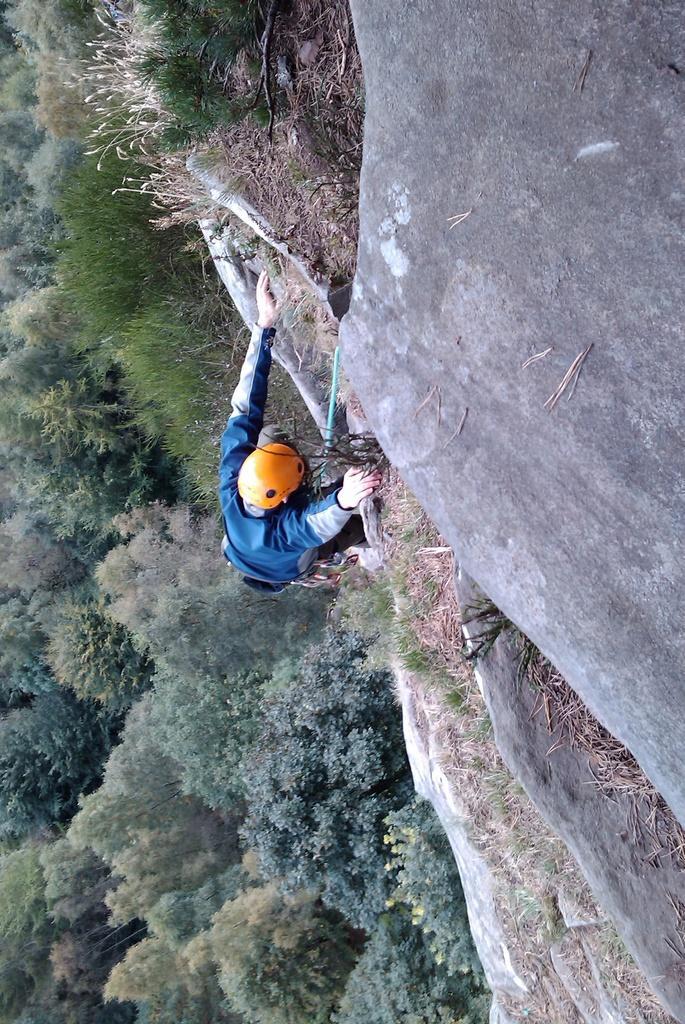Please provide a concise description of this image. In this image I can see the person and the person is wearing blue color dress and an orange color helmet. In the background I can see few trees in green color. 